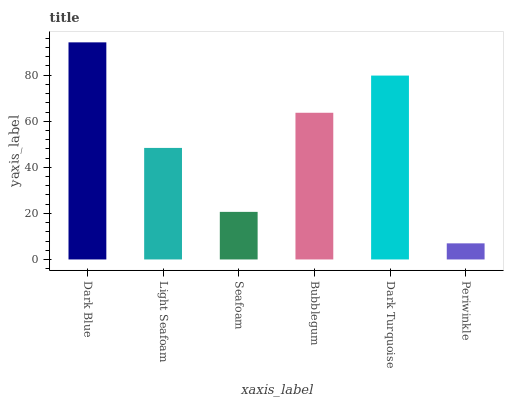Is Periwinkle the minimum?
Answer yes or no. Yes. Is Dark Blue the maximum?
Answer yes or no. Yes. Is Light Seafoam the minimum?
Answer yes or no. No. Is Light Seafoam the maximum?
Answer yes or no. No. Is Dark Blue greater than Light Seafoam?
Answer yes or no. Yes. Is Light Seafoam less than Dark Blue?
Answer yes or no. Yes. Is Light Seafoam greater than Dark Blue?
Answer yes or no. No. Is Dark Blue less than Light Seafoam?
Answer yes or no. No. Is Bubblegum the high median?
Answer yes or no. Yes. Is Light Seafoam the low median?
Answer yes or no. Yes. Is Periwinkle the high median?
Answer yes or no. No. Is Seafoam the low median?
Answer yes or no. No. 